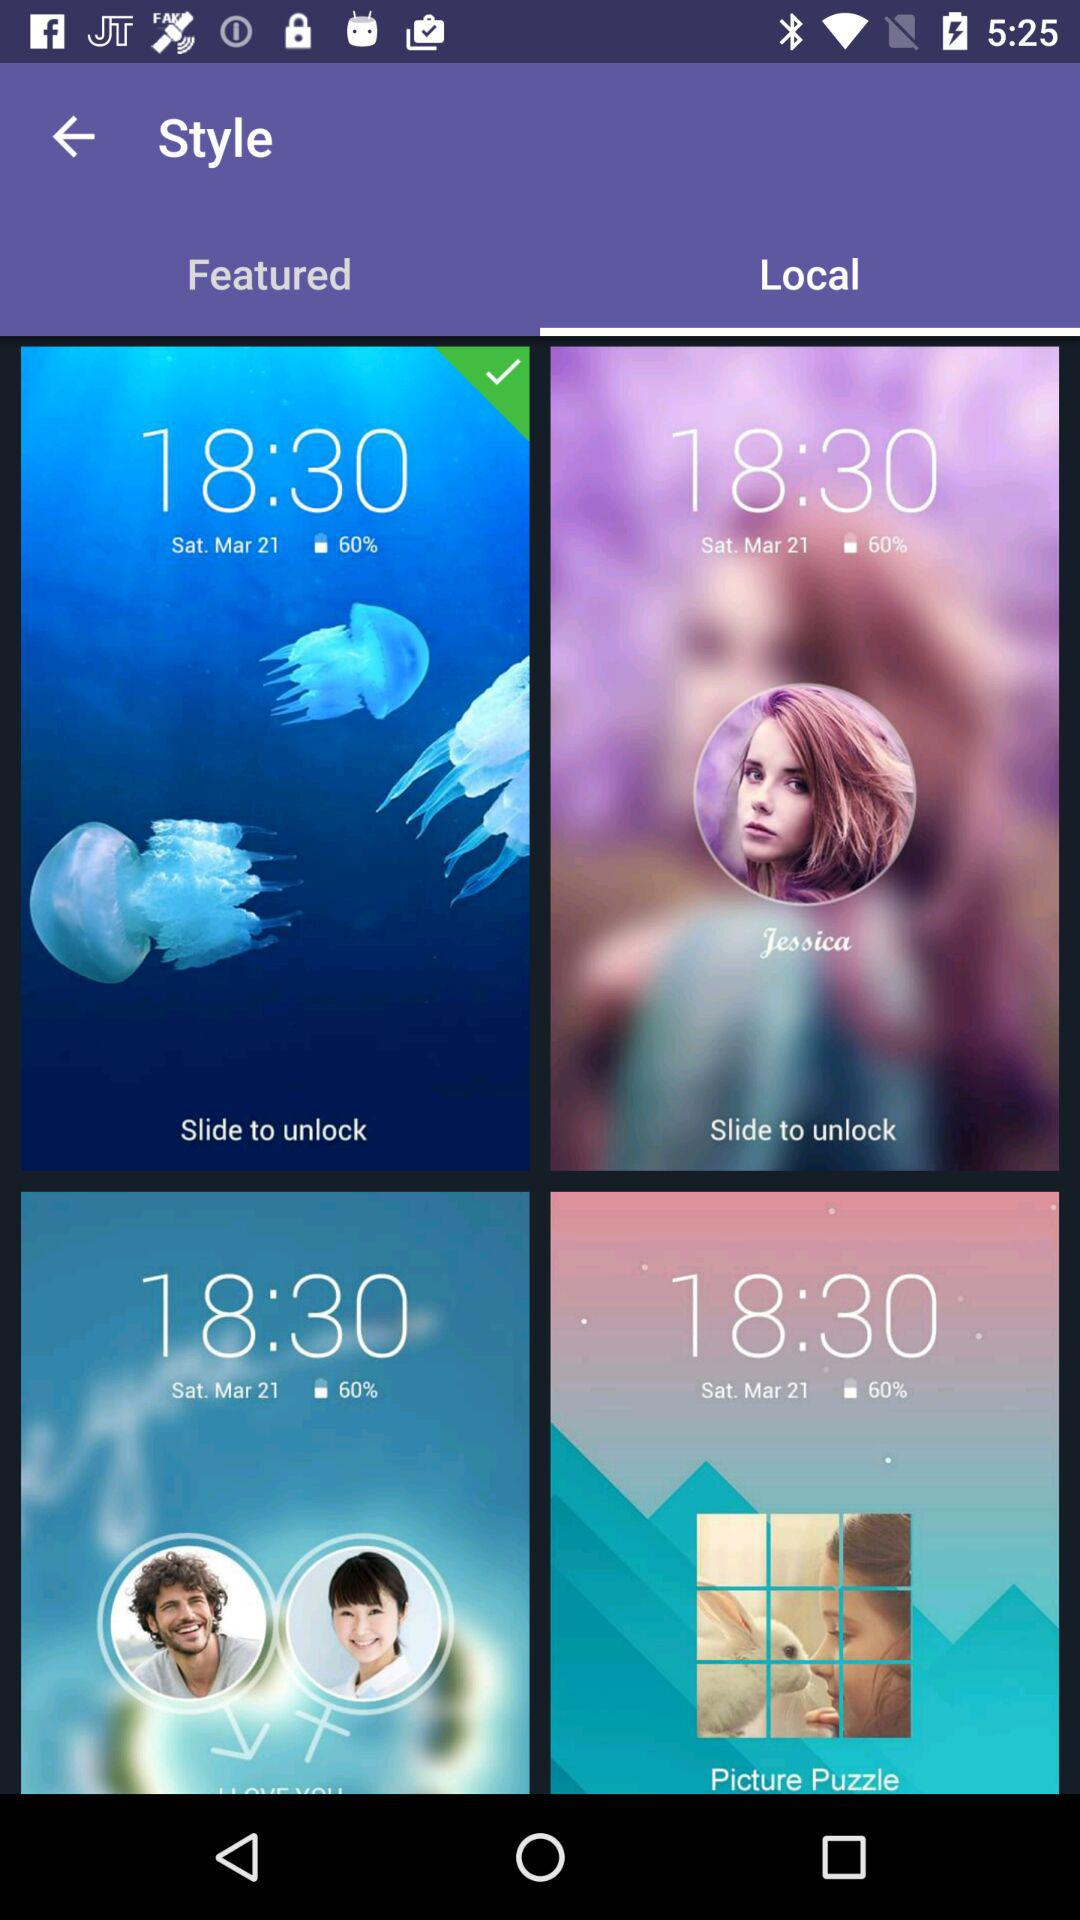How many items have a picture of a woman?
Answer the question using a single word or phrase. 2 